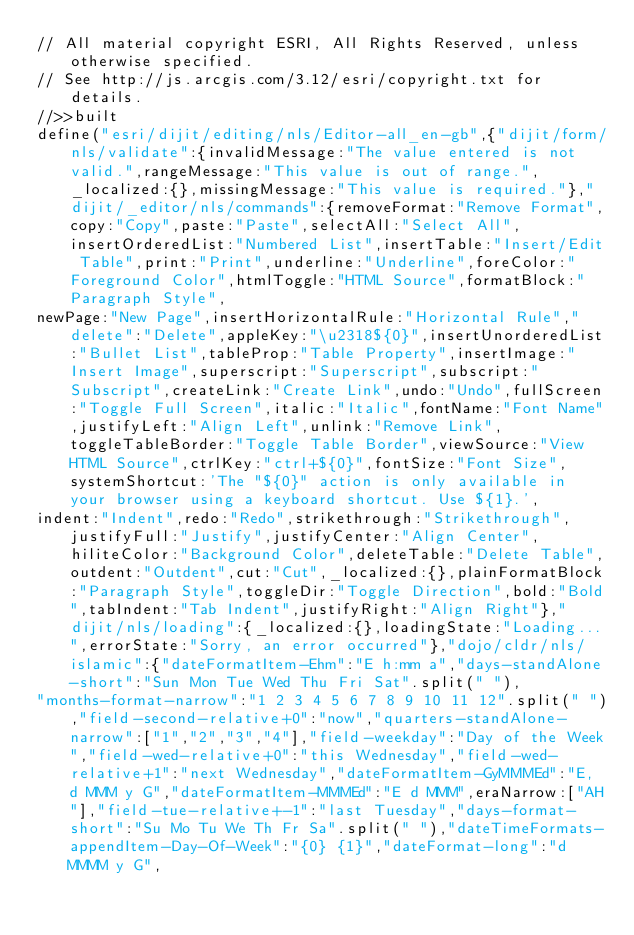<code> <loc_0><loc_0><loc_500><loc_500><_JavaScript_>// All material copyright ESRI, All Rights Reserved, unless otherwise specified.
// See http://js.arcgis.com/3.12/esri/copyright.txt for details.
//>>built
define("esri/dijit/editing/nls/Editor-all_en-gb",{"dijit/form/nls/validate":{invalidMessage:"The value entered is not valid.",rangeMessage:"This value is out of range.",_localized:{},missingMessage:"This value is required."},"dijit/_editor/nls/commands":{removeFormat:"Remove Format",copy:"Copy",paste:"Paste",selectAll:"Select All",insertOrderedList:"Numbered List",insertTable:"Insert/Edit Table",print:"Print",underline:"Underline",foreColor:"Foreground Color",htmlToggle:"HTML Source",formatBlock:"Paragraph Style",
newPage:"New Page",insertHorizontalRule:"Horizontal Rule","delete":"Delete",appleKey:"\u2318${0}",insertUnorderedList:"Bullet List",tableProp:"Table Property",insertImage:"Insert Image",superscript:"Superscript",subscript:"Subscript",createLink:"Create Link",undo:"Undo",fullScreen:"Toggle Full Screen",italic:"Italic",fontName:"Font Name",justifyLeft:"Align Left",unlink:"Remove Link",toggleTableBorder:"Toggle Table Border",viewSource:"View HTML Source",ctrlKey:"ctrl+${0}",fontSize:"Font Size",systemShortcut:'The "${0}" action is only available in your browser using a keyboard shortcut. Use ${1}.',
indent:"Indent",redo:"Redo",strikethrough:"Strikethrough",justifyFull:"Justify",justifyCenter:"Align Center",hiliteColor:"Background Color",deleteTable:"Delete Table",outdent:"Outdent",cut:"Cut",_localized:{},plainFormatBlock:"Paragraph Style",toggleDir:"Toggle Direction",bold:"Bold",tabIndent:"Tab Indent",justifyRight:"Align Right"},"dijit/nls/loading":{_localized:{},loadingState:"Loading...",errorState:"Sorry, an error occurred"},"dojo/cldr/nls/islamic":{"dateFormatItem-Ehm":"E h:mm a","days-standAlone-short":"Sun Mon Tue Wed Thu Fri Sat".split(" "),
"months-format-narrow":"1 2 3 4 5 6 7 8 9 10 11 12".split(" "),"field-second-relative+0":"now","quarters-standAlone-narrow":["1","2","3","4"],"field-weekday":"Day of the Week","field-wed-relative+0":"this Wednesday","field-wed-relative+1":"next Wednesday","dateFormatItem-GyMMMEd":"E, d MMM y G","dateFormatItem-MMMEd":"E d MMM",eraNarrow:["AH"],"field-tue-relative+-1":"last Tuesday","days-format-short":"Su Mo Tu We Th Fr Sa".split(" "),"dateTimeFormats-appendItem-Day-Of-Week":"{0} {1}","dateFormat-long":"d MMMM y G",</code> 